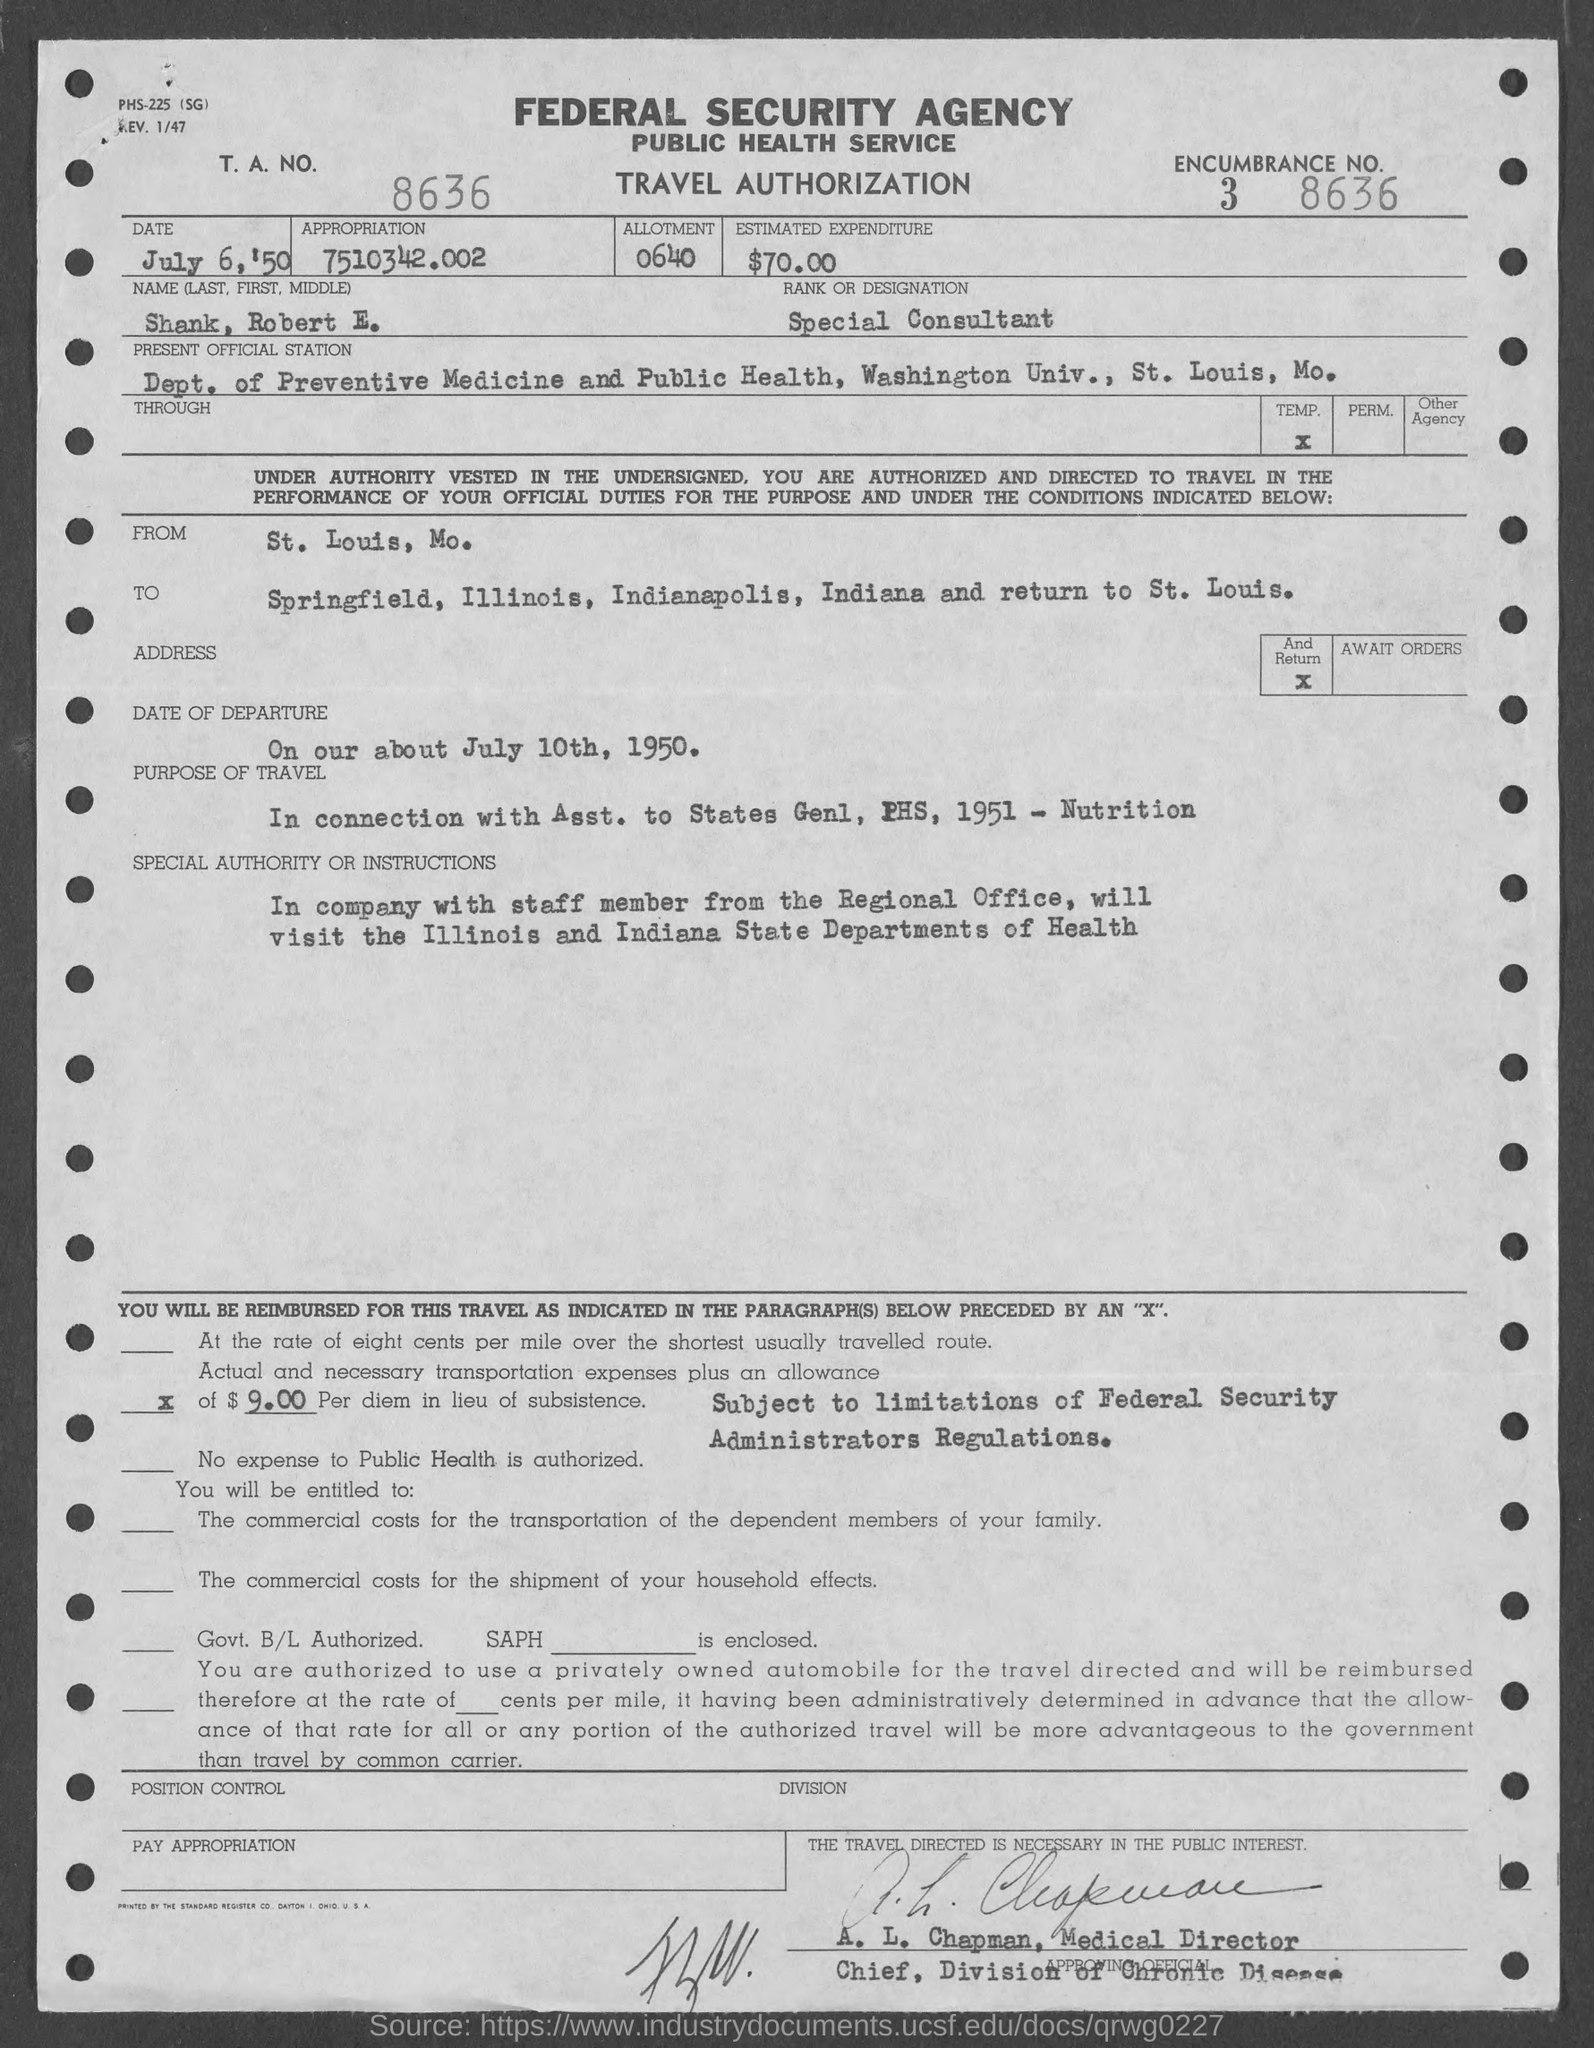Which agency is mentioned?
Offer a very short reply. Federal security agency. What is the form about?
Make the answer very short. TRAVEL AUTHORIZATION. What is the T. A. NO.?
Give a very brief answer. 8636. What is the appropriation specified?
Provide a short and direct response. 7510342.002. What is the estimated expenditure?
Keep it short and to the point. $70.00. What is the rank or designation?
Offer a very short reply. Special Consultant. When is the date of departure?
Your answer should be compact. On our about july 10th, 1950. 